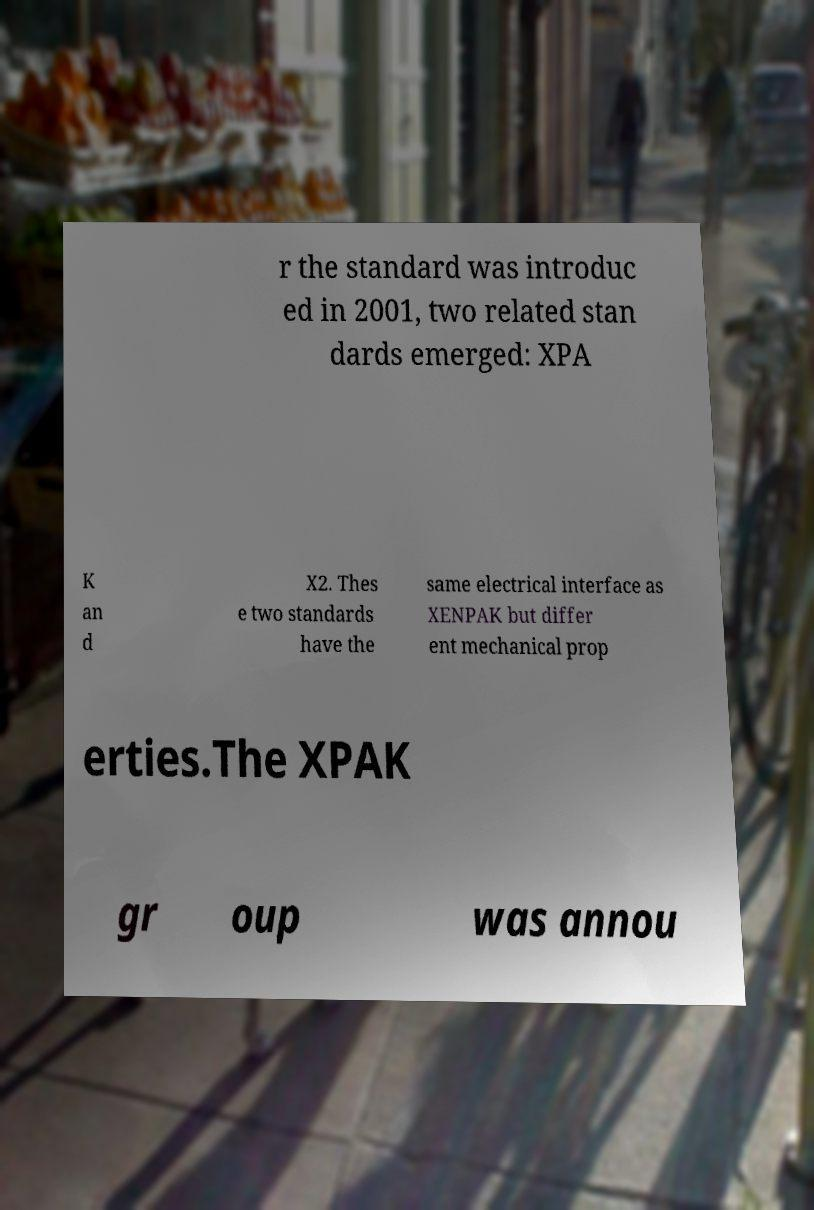Please identify and transcribe the text found in this image. r the standard was introduc ed in 2001, two related stan dards emerged: XPA K an d X2. Thes e two standards have the same electrical interface as XENPAK but differ ent mechanical prop erties.The XPAK gr oup was annou 